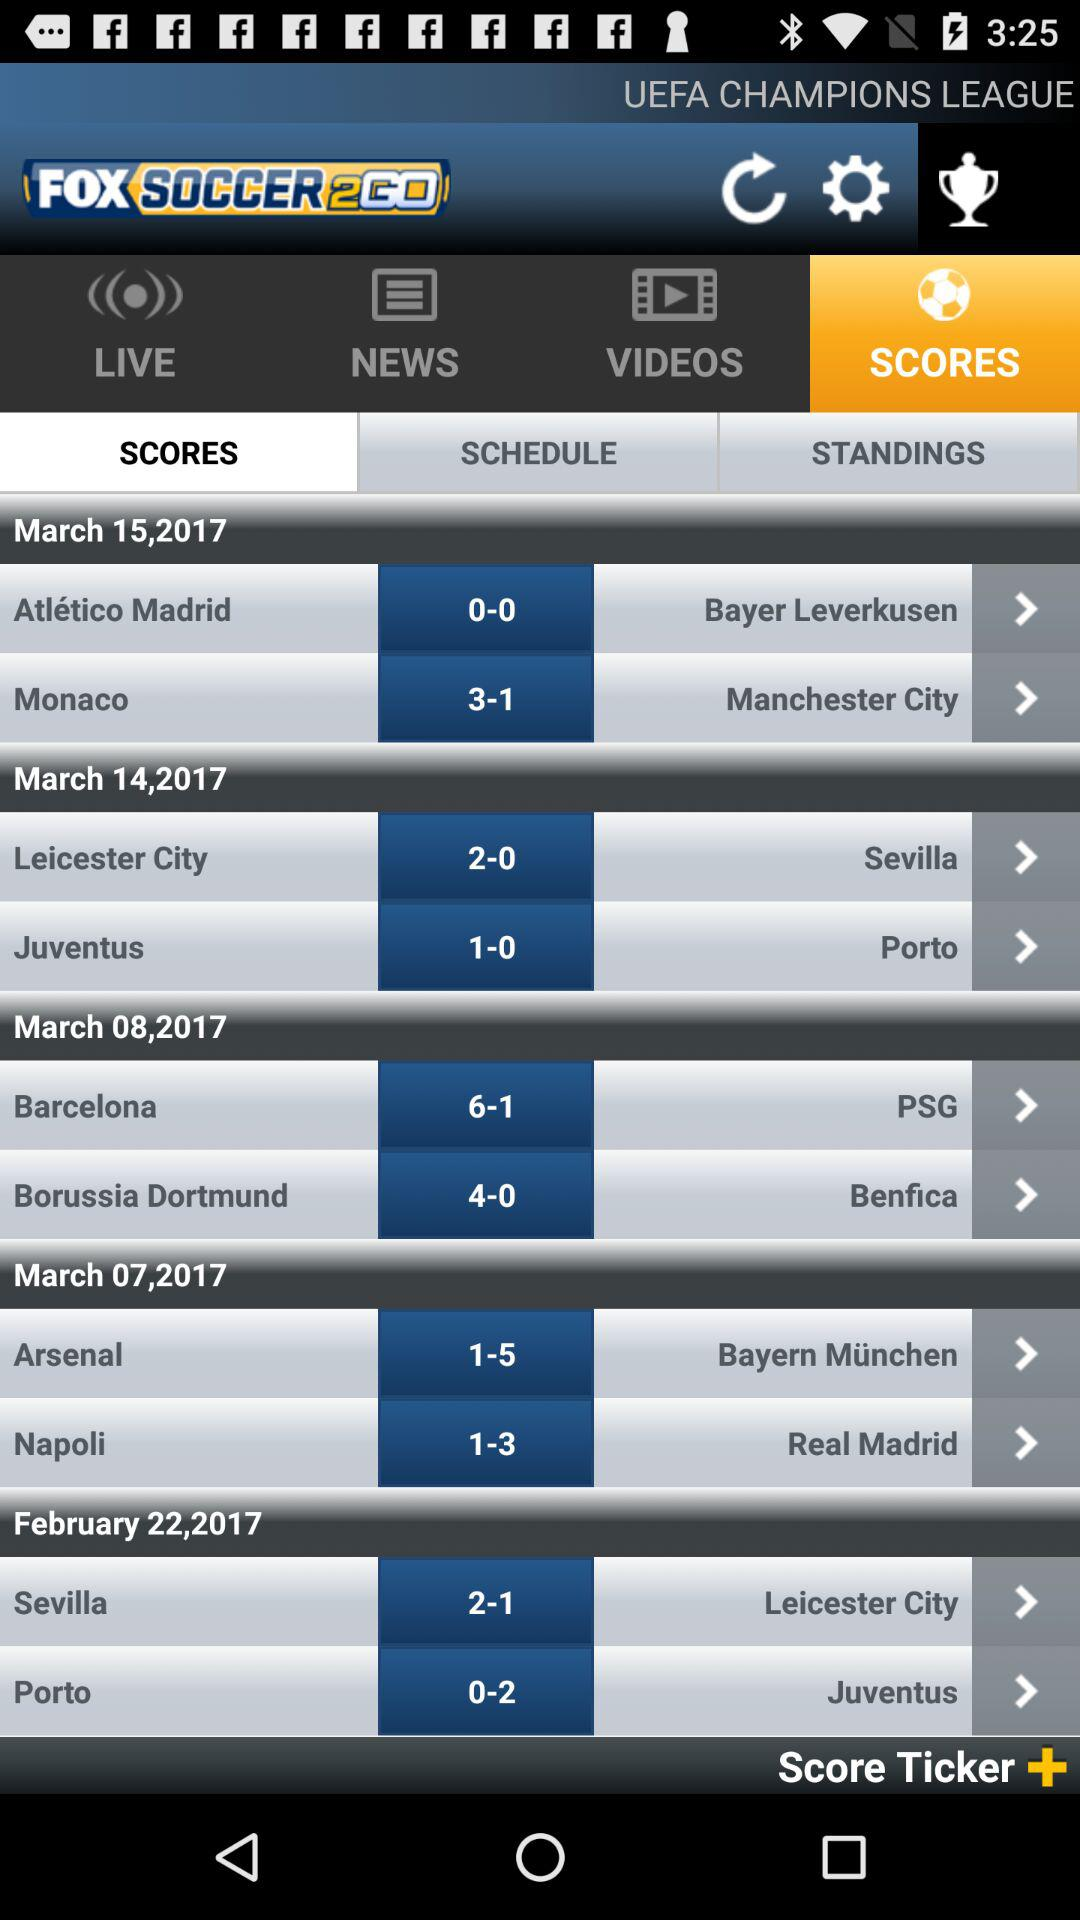Which tab is selected? The selected tab is "SCORES". 